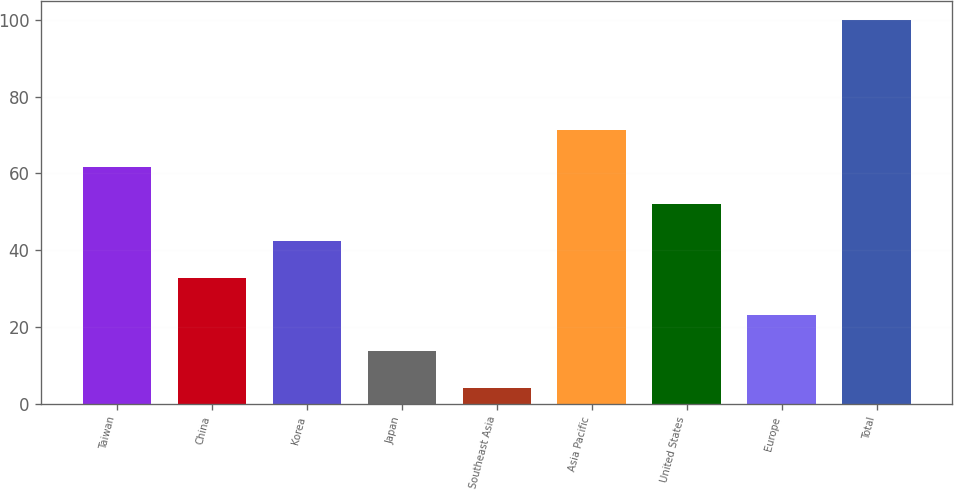<chart> <loc_0><loc_0><loc_500><loc_500><bar_chart><fcel>Taiwan<fcel>China<fcel>Korea<fcel>Japan<fcel>Southeast Asia<fcel>Asia Pacific<fcel>United States<fcel>Europe<fcel>Total<nl><fcel>61.6<fcel>32.8<fcel>42.4<fcel>13.6<fcel>4<fcel>71.2<fcel>52<fcel>23.2<fcel>100<nl></chart> 